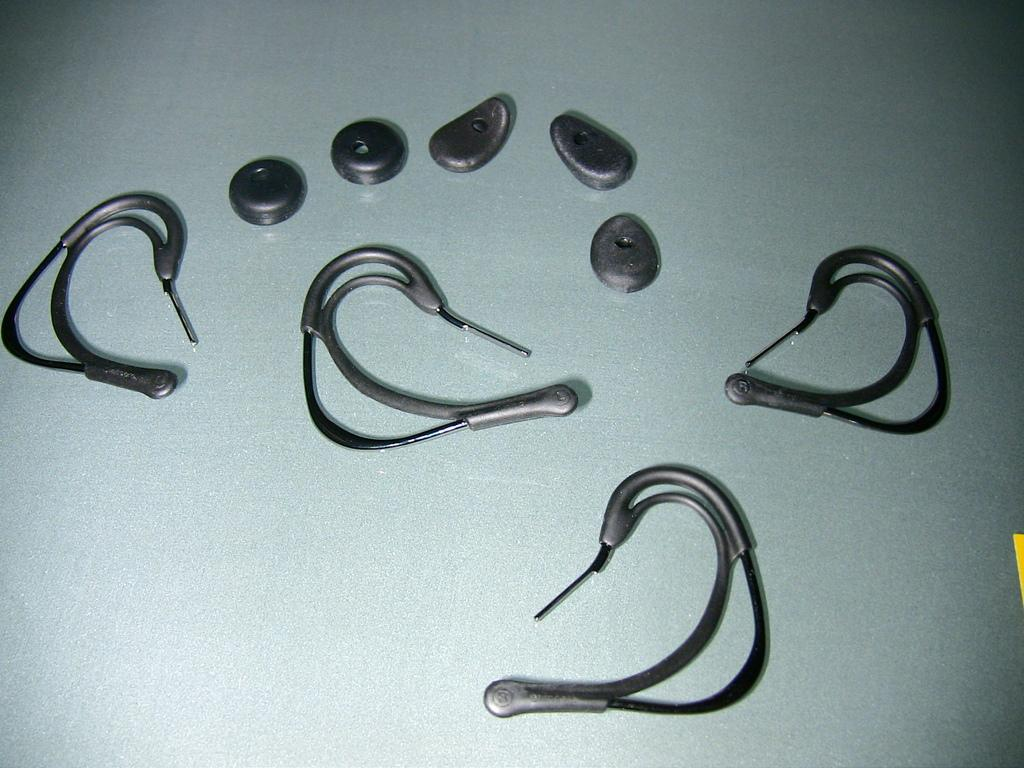What color are the objects in the image? The objects in the image are black. What color is the surface on which the objects are placed? The surface is grey. Can you see any smoke coming from the objects in the image? There is no smoke present in the image. What season is depicted in the image? The image does not depict a specific season, as there are no seasonal elements or clues provided. 